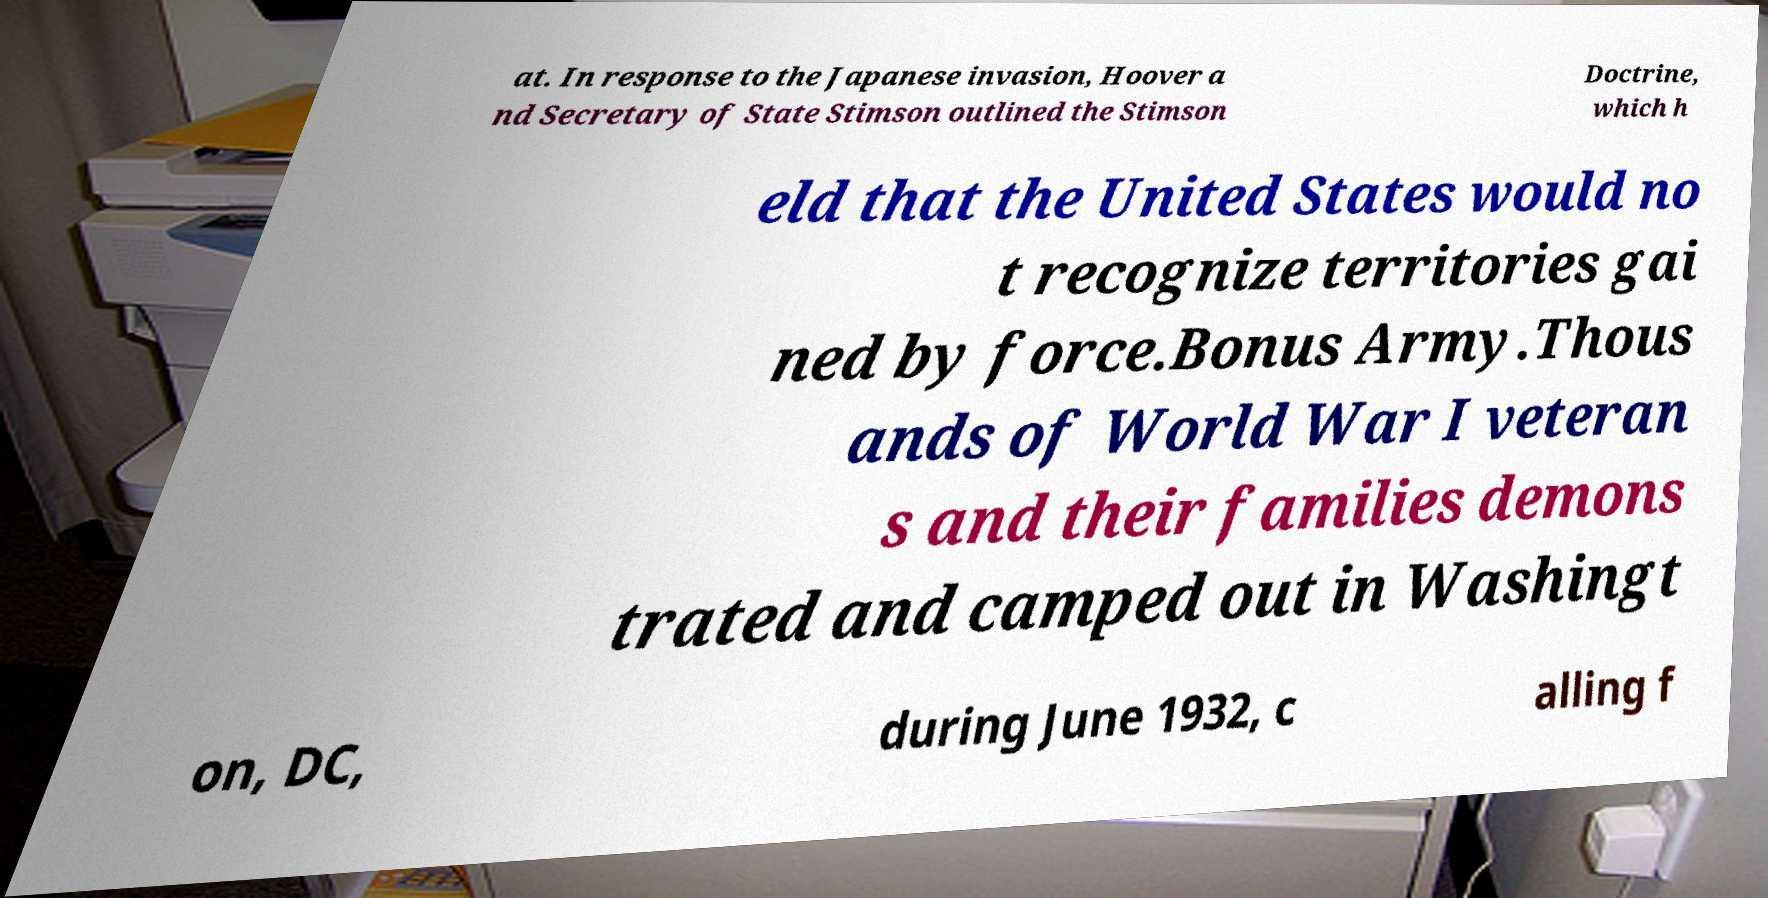Could you assist in decoding the text presented in this image and type it out clearly? at. In response to the Japanese invasion, Hoover a nd Secretary of State Stimson outlined the Stimson Doctrine, which h eld that the United States would no t recognize territories gai ned by force.Bonus Army.Thous ands of World War I veteran s and their families demons trated and camped out in Washingt on, DC, during June 1932, c alling f 